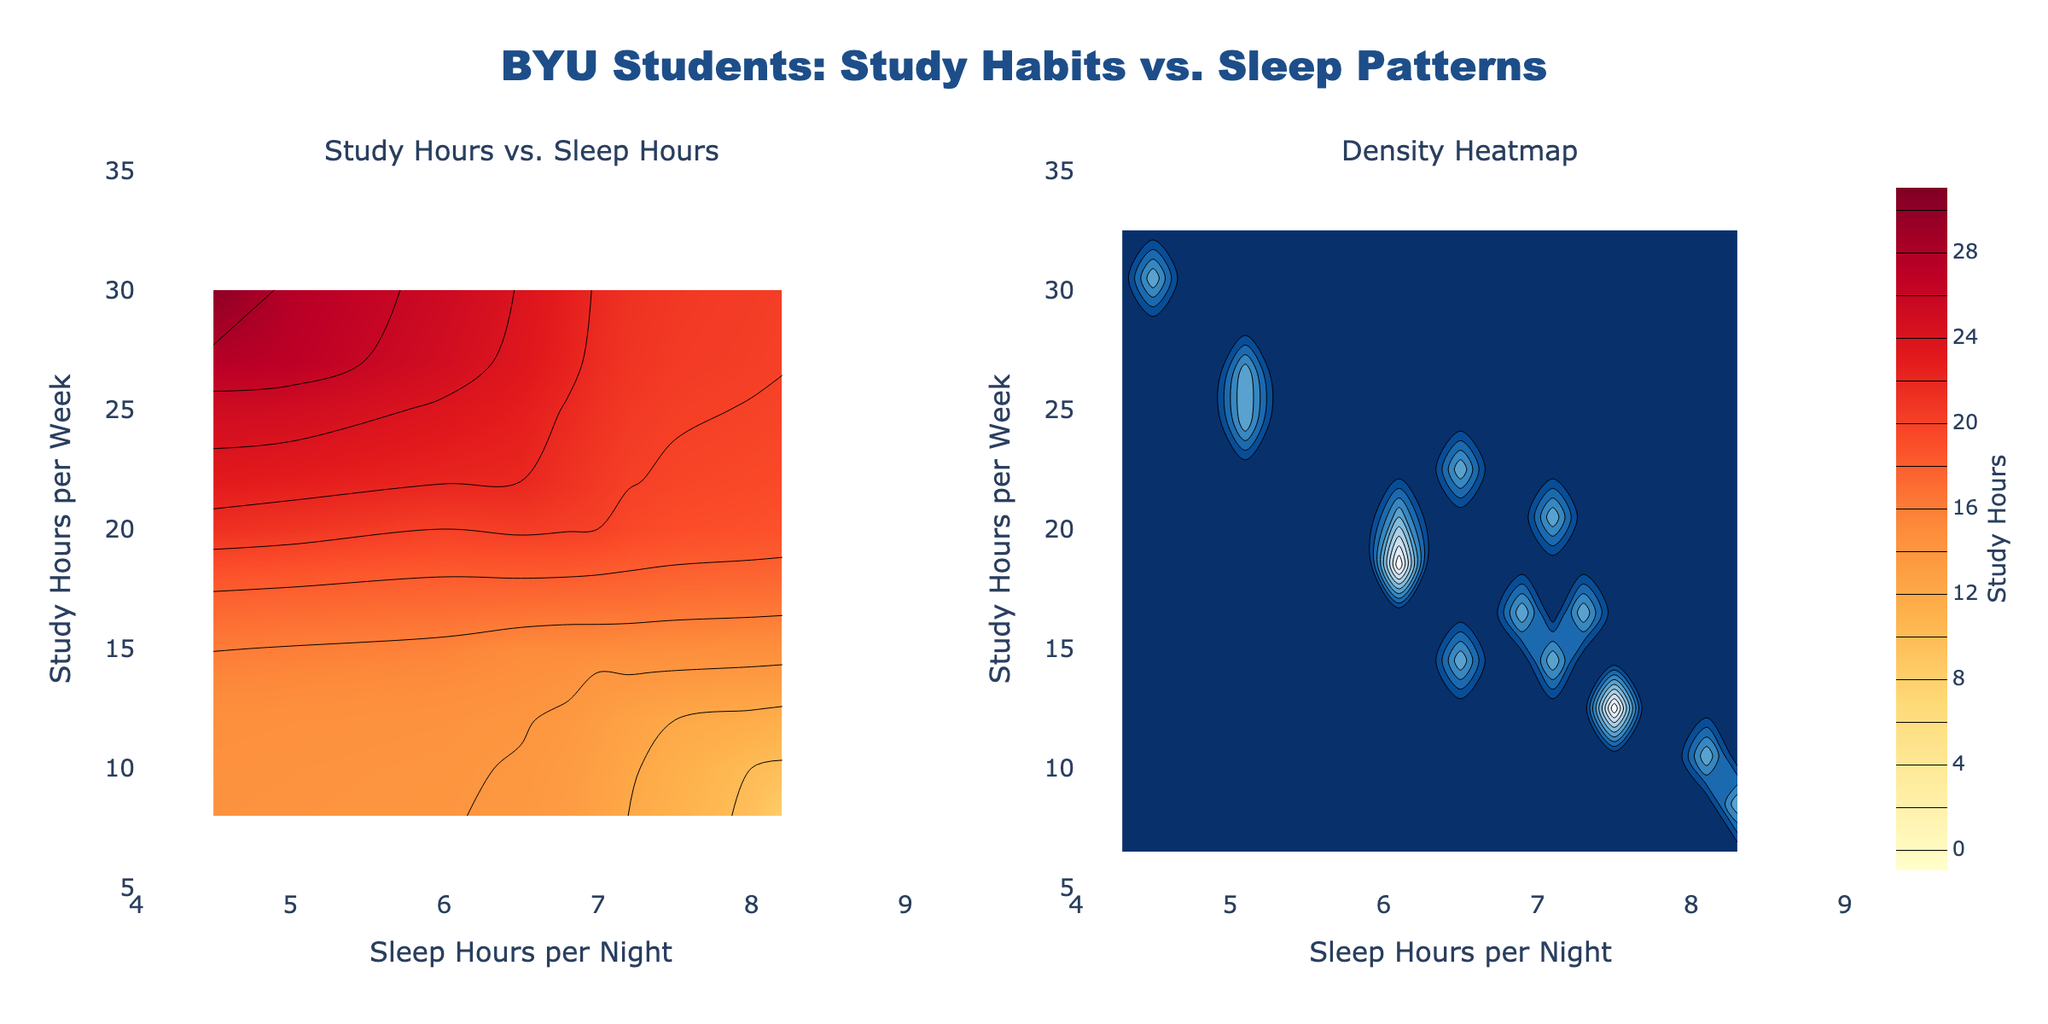How many subplot titles are there in this figure? There are two subplots in the figure and each has a title. One titled "Study Hours vs. Sleep Hours" and the other titled "Density Heatmap".
Answer: 2 What color scale is used in the Study Hours vs. Sleep Hours subplot? The contour plot colors range from yellow to red, indicating the study hours with a 'YlOrRd' colorscale applied.
Answer: Yellow to Red In the Study Hours vs. Sleep Hours plot, what range of sleep hours per night is displayed on the x-axis? The x-axis representing sleep hours per night has a range from 4 to 9 hours.
Answer: 4 to 9 Which has more color density towards higher study hours, the contour plot or the density heatmap? The density heatmap on the right shows more color density towards higher study hours compared to the contour plot on the left.
Answer: Density heatmap What is the relationship between Study Hours and Sleep Hours visible in the density heatmap? The density heatmap uses a blue colorscale and shows higher density of study hours around average sleep hours. Higher study hours appear to be correlated with fewer sleep hours.
Answer: More study, less sleep What are the names of the axes in the Density Heatmap? The x-axis is named "Sleep Hours per Night" and the y-axis is named "Study Hours per Week".
Answer: Sleep Hours per Night and Study Hours per Week What is the title of the plot? The main title of the plot is "BYU Students: Study Habits vs. Sleep Patterns", located at the top center of the figure.
Answer: BYU Students: Study Habits vs. Sleep Patterns How are the colors on the Study Hours vs. Sleep Hours subplot mapped to the values? The colors on this subplot are mapped to study hours from yellow (lower values) to red (higher values), with each contour line representing a study hour increment.
Answer: Yellow to Red Which subplot contains a histogram? The histogram is not explicitly shown, but it is related to the density heatmap on the right subplot, as indicated by the 2D binning shown in contours.
Answer: Density heatmap 